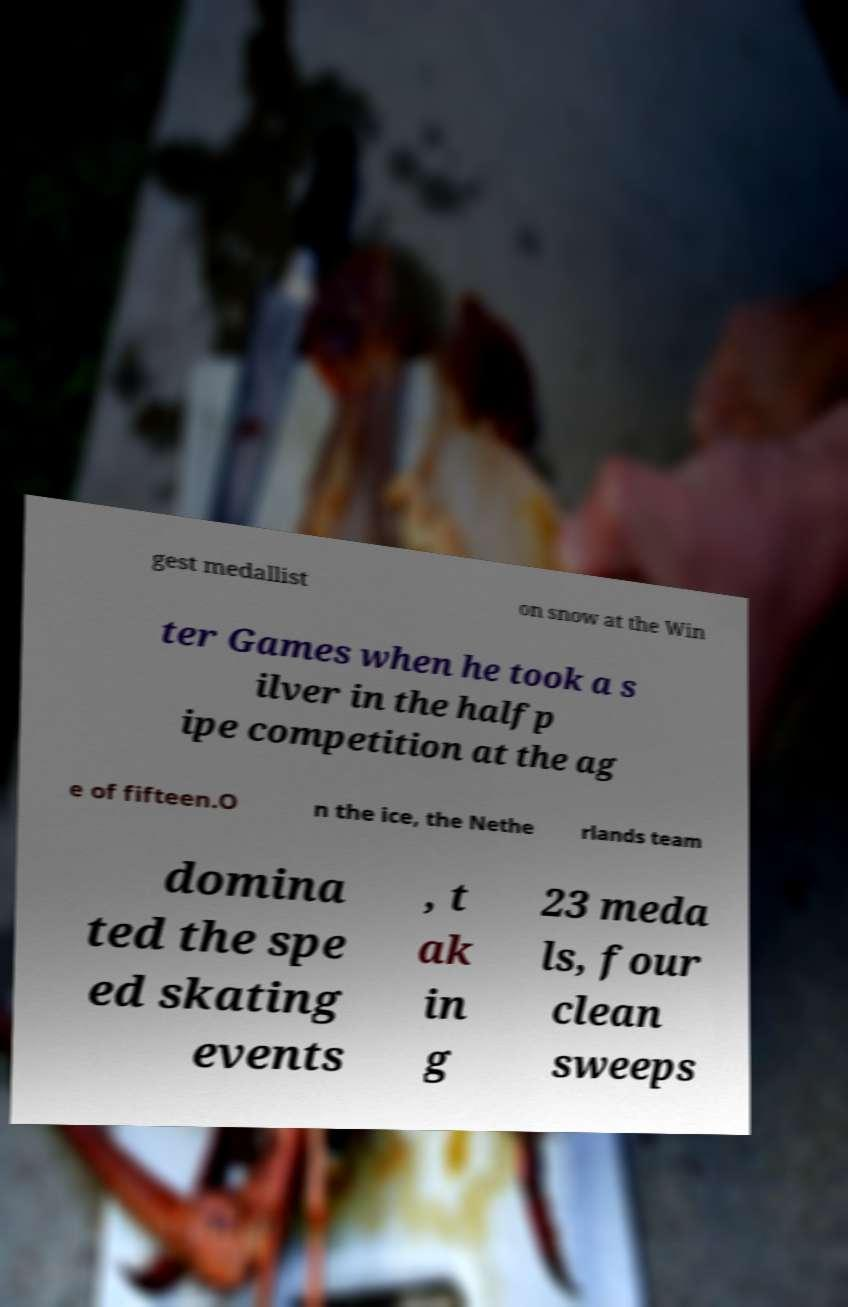I need the written content from this picture converted into text. Can you do that? gest medallist on snow at the Win ter Games when he took a s ilver in the halfp ipe competition at the ag e of fifteen.O n the ice, the Nethe rlands team domina ted the spe ed skating events , t ak in g 23 meda ls, four clean sweeps 